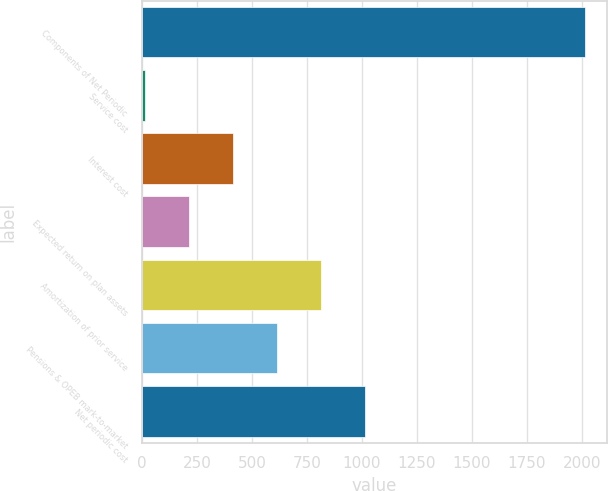Convert chart to OTSL. <chart><loc_0><loc_0><loc_500><loc_500><bar_chart><fcel>Components of Net Periodic<fcel>Service cost<fcel>Interest cost<fcel>Expected return on plan assets<fcel>Amortization of prior service<fcel>Pensions & OPEB mark-to-market<fcel>Net periodic cost<nl><fcel>2013<fcel>13<fcel>413<fcel>213<fcel>813<fcel>613<fcel>1013<nl></chart> 